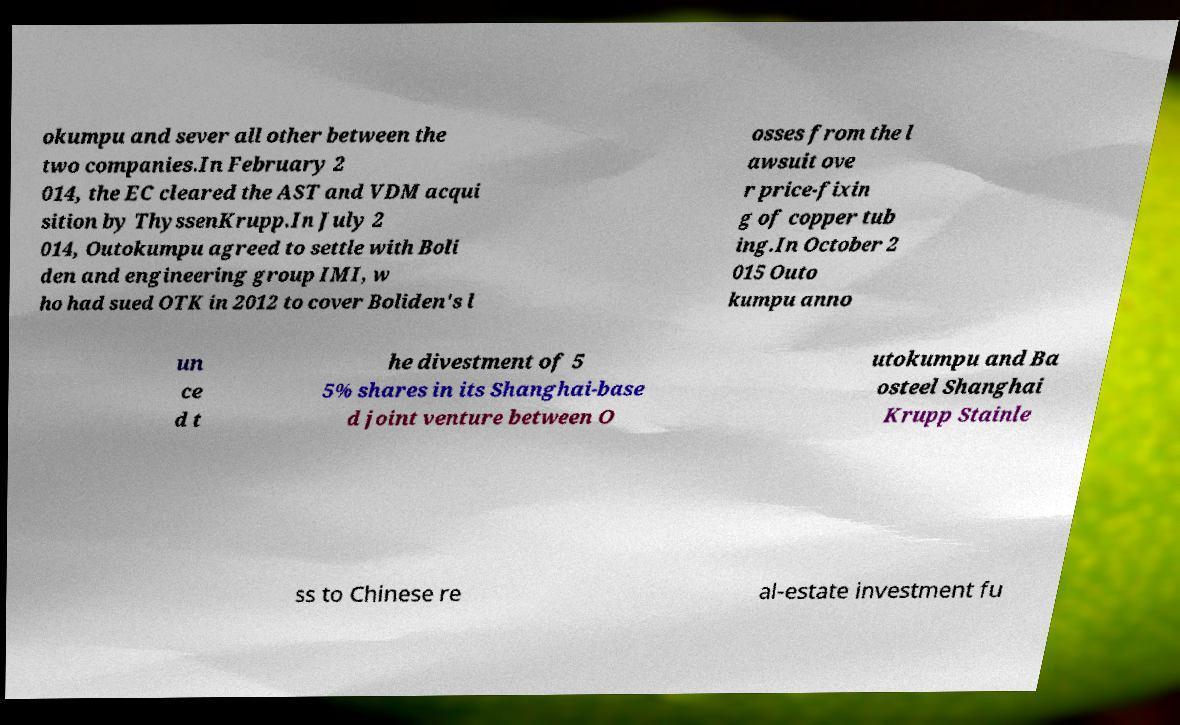What messages or text are displayed in this image? I need them in a readable, typed format. okumpu and sever all other between the two companies.In February 2 014, the EC cleared the AST and VDM acqui sition by ThyssenKrupp.In July 2 014, Outokumpu agreed to settle with Boli den and engineering group IMI, w ho had sued OTK in 2012 to cover Boliden's l osses from the l awsuit ove r price-fixin g of copper tub ing.In October 2 015 Outo kumpu anno un ce d t he divestment of 5 5% shares in its Shanghai-base d joint venture between O utokumpu and Ba osteel Shanghai Krupp Stainle ss to Chinese re al-estate investment fu 